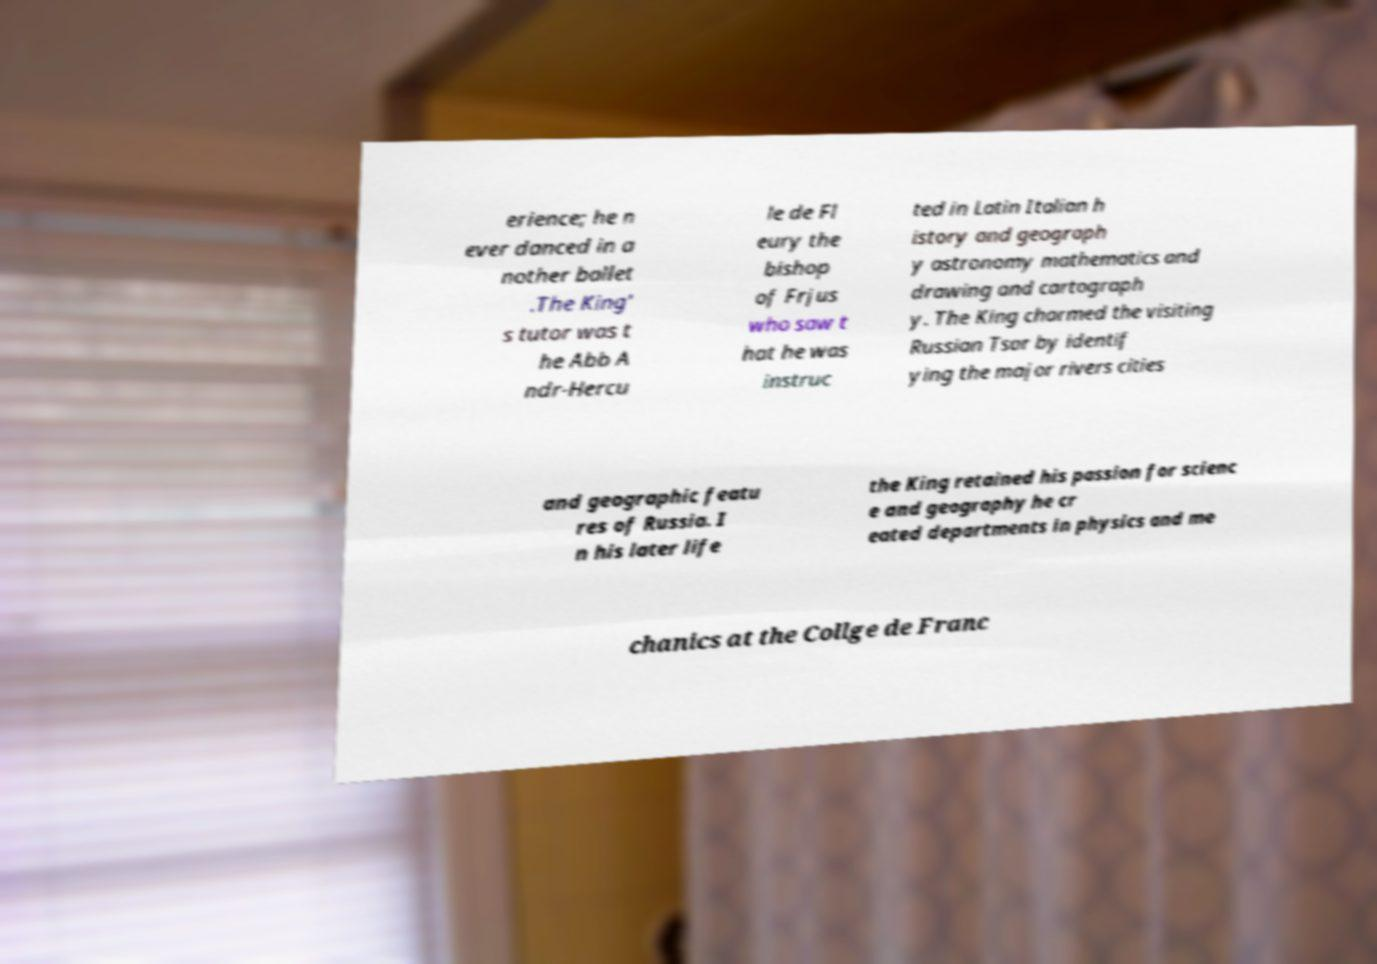What messages or text are displayed in this image? I need them in a readable, typed format. erience; he n ever danced in a nother ballet .The King' s tutor was t he Abb A ndr-Hercu le de Fl eury the bishop of Frjus who saw t hat he was instruc ted in Latin Italian h istory and geograph y astronomy mathematics and drawing and cartograph y. The King charmed the visiting Russian Tsar by identif ying the major rivers cities and geographic featu res of Russia. I n his later life the King retained his passion for scienc e and geography he cr eated departments in physics and me chanics at the Collge de Franc 